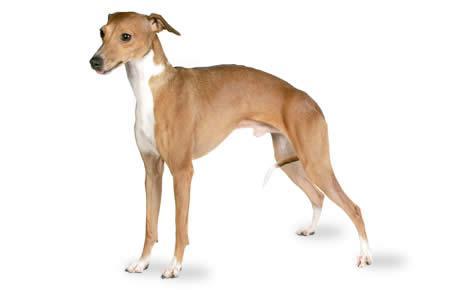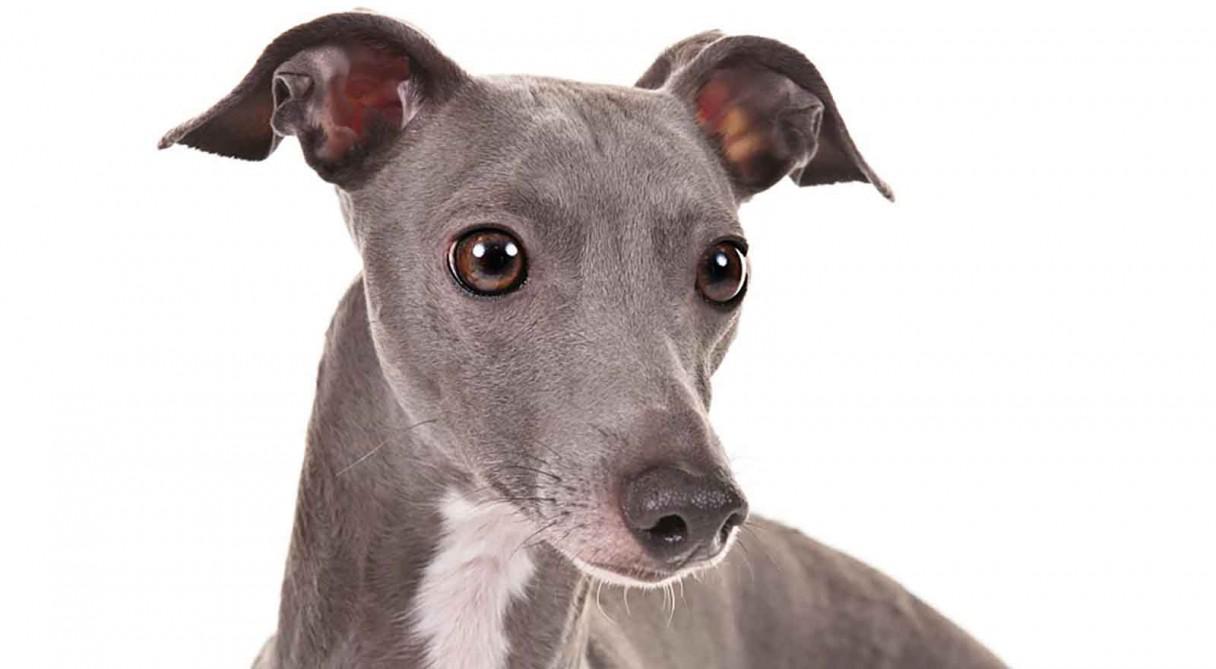The first image is the image on the left, the second image is the image on the right. Assess this claim about the two images: "Left image shows a dog with a bright white neck marking.". Correct or not? Answer yes or no. Yes. 